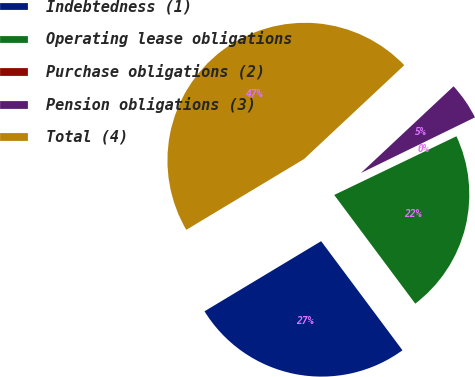<chart> <loc_0><loc_0><loc_500><loc_500><pie_chart><fcel>Indebtedness (1)<fcel>Operating lease obligations<fcel>Purchase obligations (2)<fcel>Pension obligations (3)<fcel>Total (4)<nl><fcel>26.58%<fcel>21.93%<fcel>0.1%<fcel>4.75%<fcel>46.64%<nl></chart> 